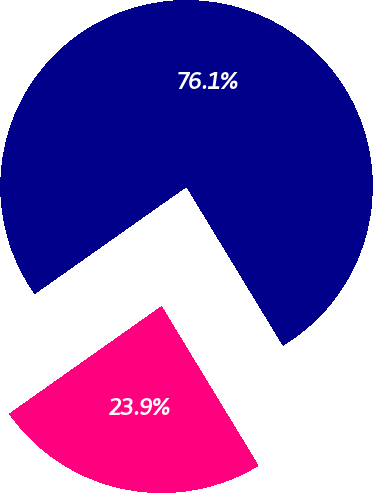Convert chart. <chart><loc_0><loc_0><loc_500><loc_500><pie_chart><fcel>Residential<fcel>Commercial<nl><fcel>76.09%<fcel>23.91%<nl></chart> 